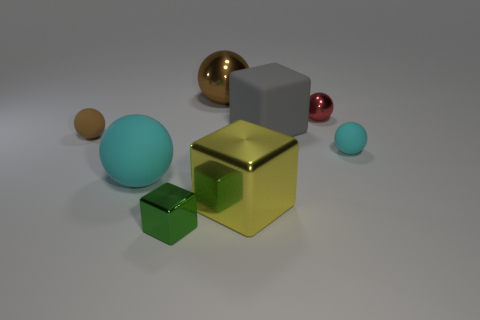Subtract all brown metal balls. How many balls are left? 4 Subtract all gray cubes. How many cubes are left? 2 Subtract 2 blocks. How many blocks are left? 1 Add 2 big cyan spheres. How many objects exist? 10 Subtract all matte spheres. Subtract all yellow shiny blocks. How many objects are left? 4 Add 4 gray matte cubes. How many gray matte cubes are left? 5 Add 2 blue metal blocks. How many blue metal blocks exist? 2 Subtract 0 purple blocks. How many objects are left? 8 Subtract all blocks. How many objects are left? 5 Subtract all blue balls. Subtract all green cylinders. How many balls are left? 5 